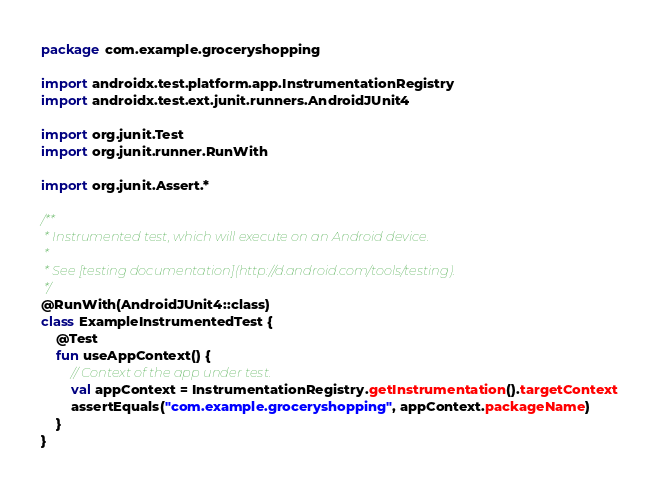<code> <loc_0><loc_0><loc_500><loc_500><_Kotlin_>package com.example.groceryshopping

import androidx.test.platform.app.InstrumentationRegistry
import androidx.test.ext.junit.runners.AndroidJUnit4

import org.junit.Test
import org.junit.runner.RunWith

import org.junit.Assert.*

/**
 * Instrumented test, which will execute on an Android device.
 *
 * See [testing documentation](http://d.android.com/tools/testing).
 */
@RunWith(AndroidJUnit4::class)
class ExampleInstrumentedTest {
    @Test
    fun useAppContext() {
        // Context of the app under test.
        val appContext = InstrumentationRegistry.getInstrumentation().targetContext
        assertEquals("com.example.groceryshopping", appContext.packageName)
    }
}</code> 